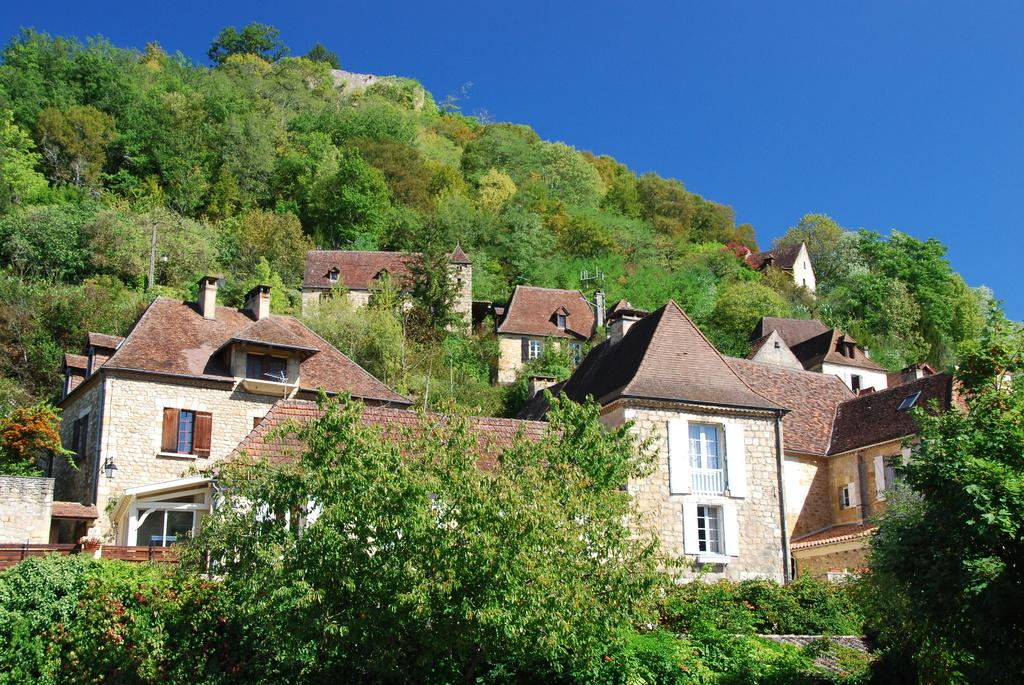What is the main subject of the image? The main subject of the image is many houses. What can be seen surrounding the houses in the image? The houses are surrounded by trees. What color is the sky in the image? The sky is blue in the image. Can you tell me how many pairs of scissors are visible in the image? There are no scissors present in the image. Is there an umbrella being used by anyone in the image? There is no umbrella present in the image. 